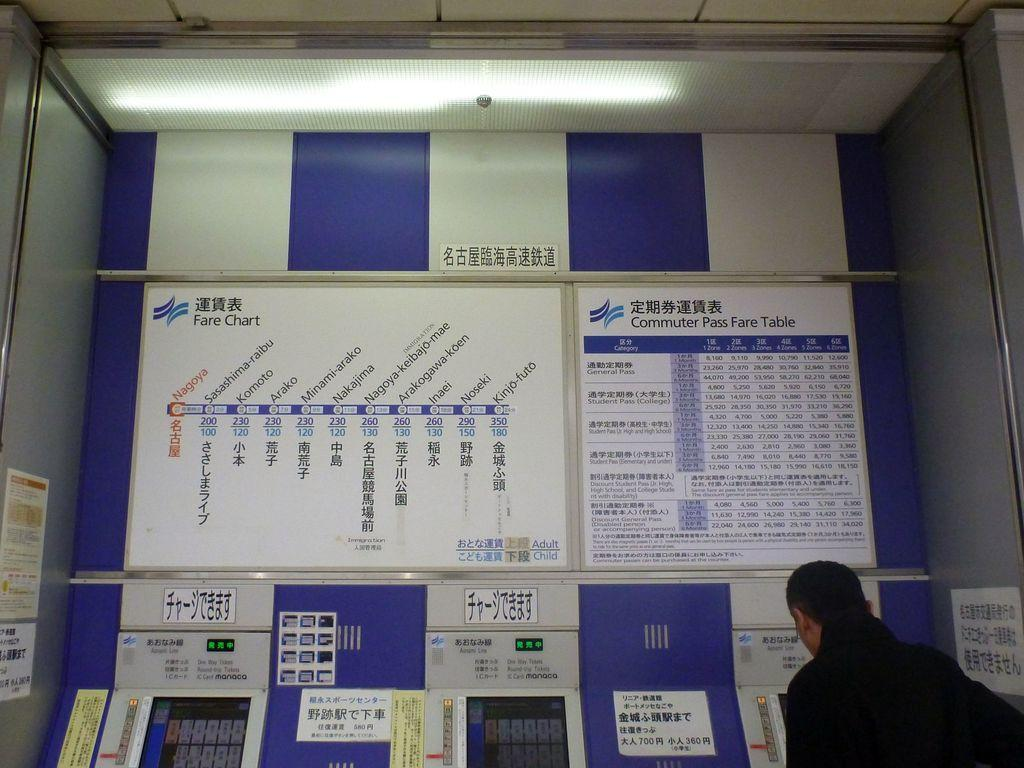<image>
Offer a succinct explanation of the picture presented. A table showing the commuter fares is on the wall above the machines. 